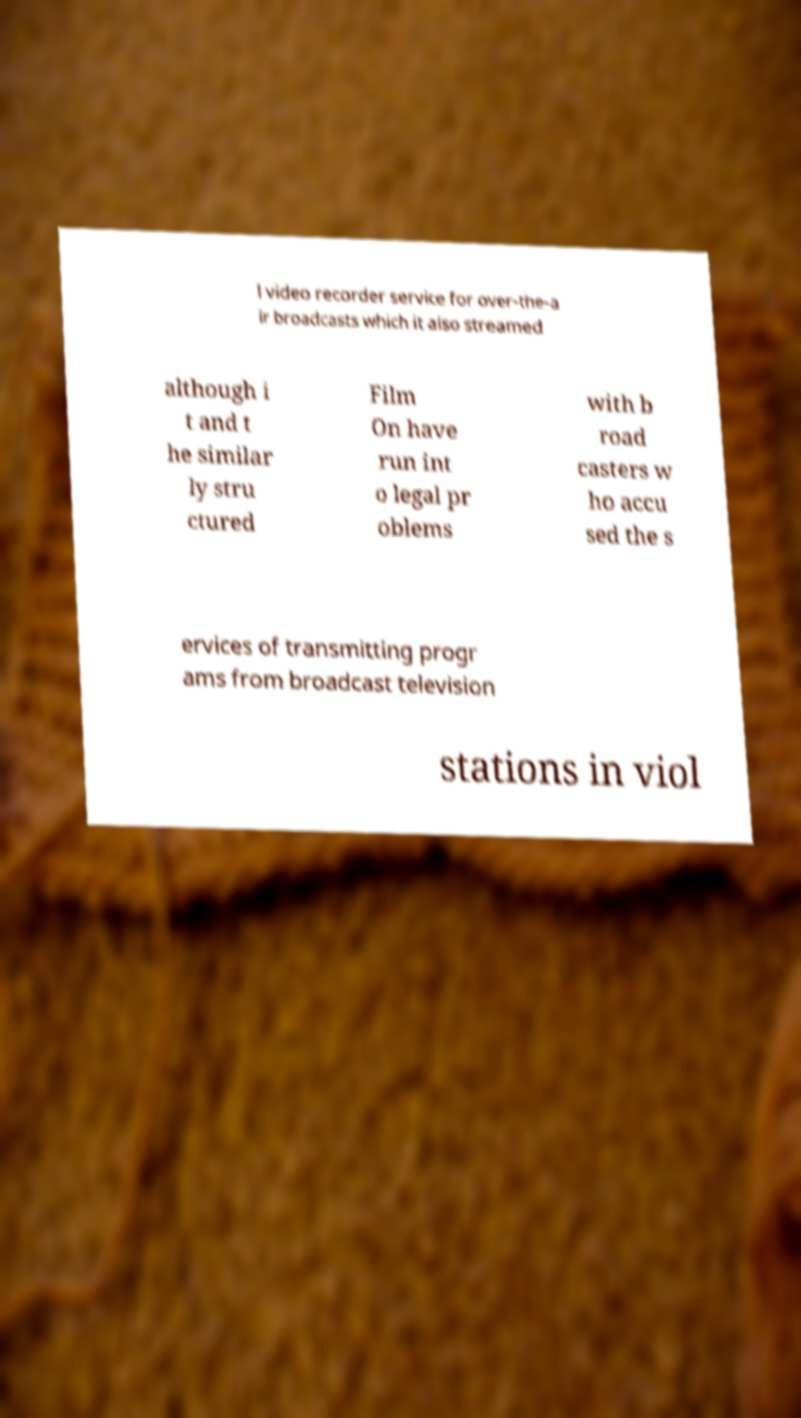I need the written content from this picture converted into text. Can you do that? l video recorder service for over-the-a ir broadcasts which it also streamed although i t and t he similar ly stru ctured Film On have run int o legal pr oblems with b road casters w ho accu sed the s ervices of transmitting progr ams from broadcast television stations in viol 